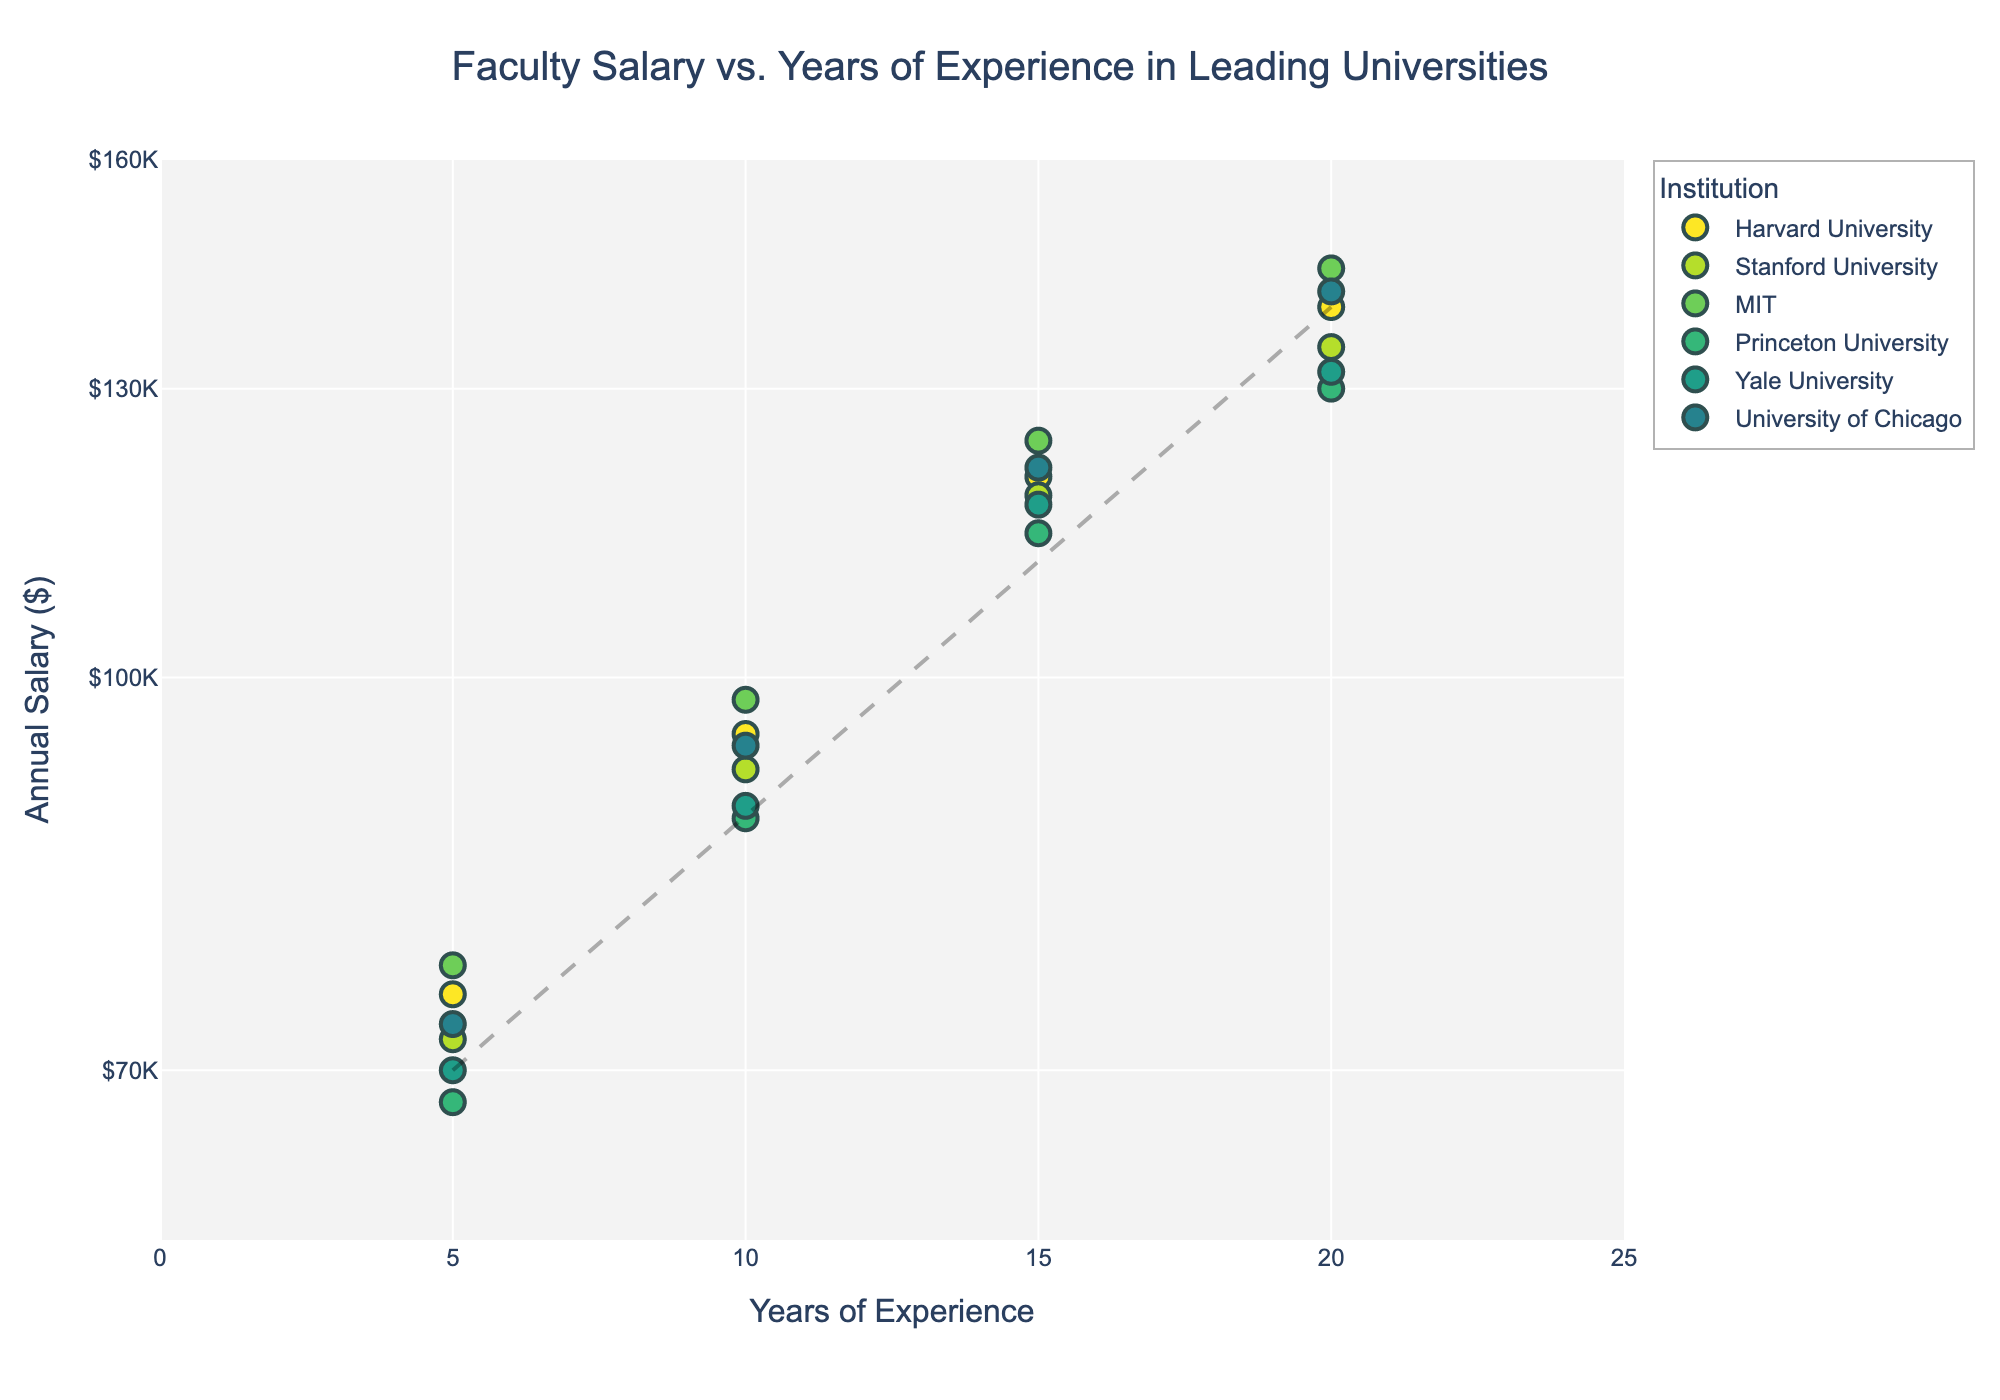What is the title of the figure? The title is displayed at the top of the figure. The title helps in understanding what the plot represents.
Answer: Faculty Salary vs. Years of Experience in Leading Universities How are the Institutions differentiated in the scatter plot? Each institution is represented by a unique color that helps in distinguishing between different data points.
Answer: Different colors What are the x-axis and y-axis labels for this graph? The x-axis label represents the years of experience, and the y-axis represents annual salary in dollars.
Answer: Years of Experience, Annual Salary ($) How many data points are plotted for Harvard University? Each institution has data points for 5, 10, 15, and 20 years of experience. Count Harvard's data points that match these criteria.
Answer: Four data points What is the trend in faculty salaries as years of experience increase? The trend line added to the plot indicates that faculty salaries tend to increase as years of experience increase. This is reflected in the upward slope of the trend line.
Answer: Increase Which institution has the highest starting salary (5 years of experience)? Compare the data points for 5 years of experience across all institutions by looking at the y-coordinate's highest value.
Answer: MIT By how much does the annual salary increase from 10 to 20 years of experience at Stanford University? Find the salaries at 10 and 20 years of experience for Stanford and calculate the difference: 135000 - 92000.
Answer: $43,000 Which institution shows the smallest increase in salary from 5 to 20 years of experience? Calculate the salary difference for each institution and compare them to find the smallest increase: Harvard (140000-75000), Stanford (135000-72000), MIT (145000-77000), Princeton (130000-68000), Yale (132000-70000), UChicago (142000-73000).
Answer: Princeton University At 15 years of experience, which two institutions have the most similar faculty salaries? Look at the salaries for all institutions at 15 years of experience and identify the closest values: Harvard (120000), Stanford (118000), MIT (124000), Princeton (114000), Yale (117000), UChicago (121000).
Answer: Stanford and Yale What is the approximate salary at 20 years of experience for the lowest-paying institution at that experience level? Identify and compare the salaries at 20 years of experience for all institutions. The minimum salary for 20 years of experience is the answer.
Answer: $130,000 (Princeton University) 